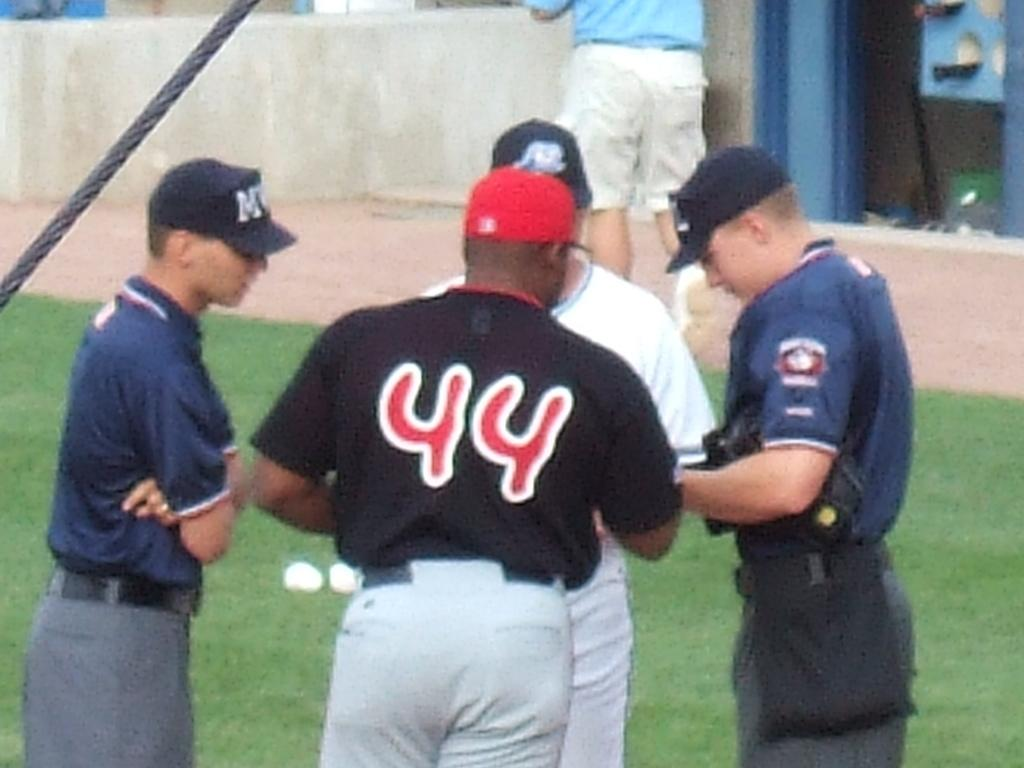<image>
Write a terse but informative summary of the picture. Baseball coach and player that are talking over a game with the umpires, the coach is # 44. 